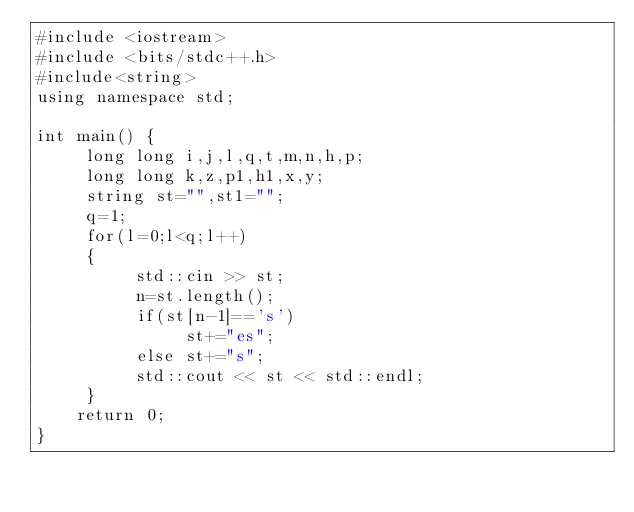<code> <loc_0><loc_0><loc_500><loc_500><_C++_>#include <iostream>
#include <bits/stdc++.h>
#include<string>
using namespace std;

int main() {
     long long i,j,l,q,t,m,n,h,p;
     long long k,z,p1,h1,x,y;
     string st="",st1="";
     q=1;
     for(l=0;l<q;l++)
     {
          std::cin >> st;
          n=st.length();
          if(st[n-1]=='s')
               st+="es";
          else st+="s";
          std::cout << st << std::endl;
     }
    return 0;
}</code> 